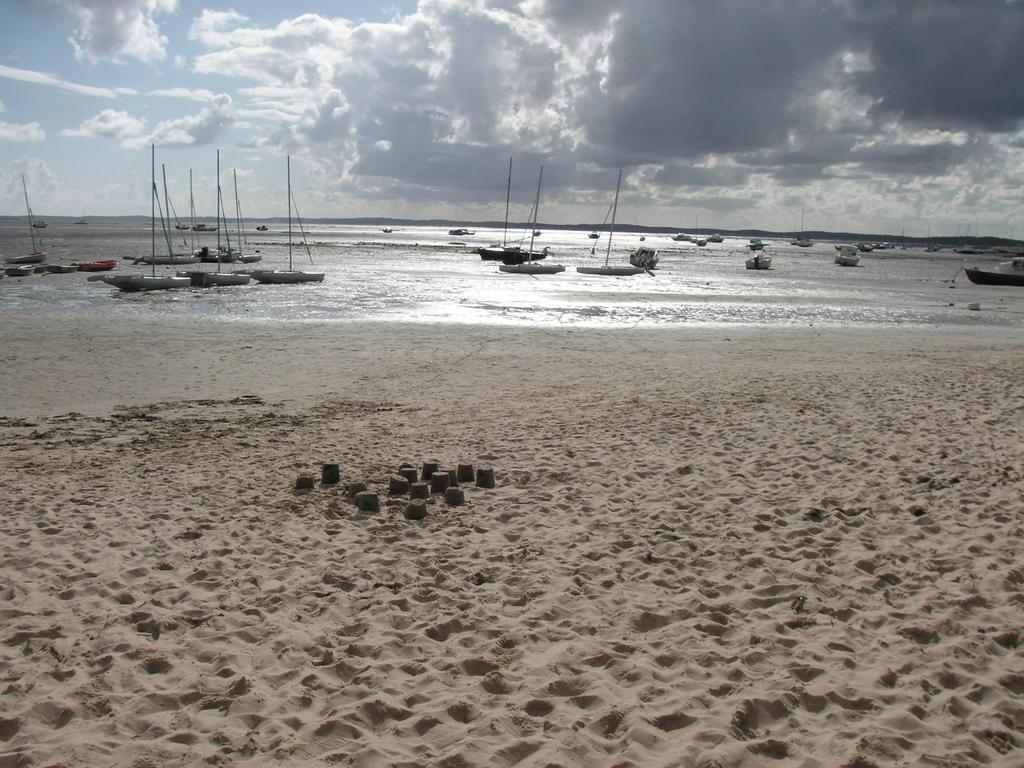What type of vehicles can be seen in the water in the image? There are boats in the water in the image. What is visible at the top of the image? The sky is visible at the top of the image. What can be seen in the sky? There are clouds in the sky. What type of terrain is present at the bottom of the image? Sand is present at the bottom of the image. What else is visible at the bottom of the image? Water is visible at the bottom of the image. What type of machine is being operated by the actor in the image? There is no machine or actor present in the image; it features boats in the water, the sky, clouds, sand, and water. What type of animal can be seen swimming in the water in the image? There are no animals visible in the image; it features boats in the water. 